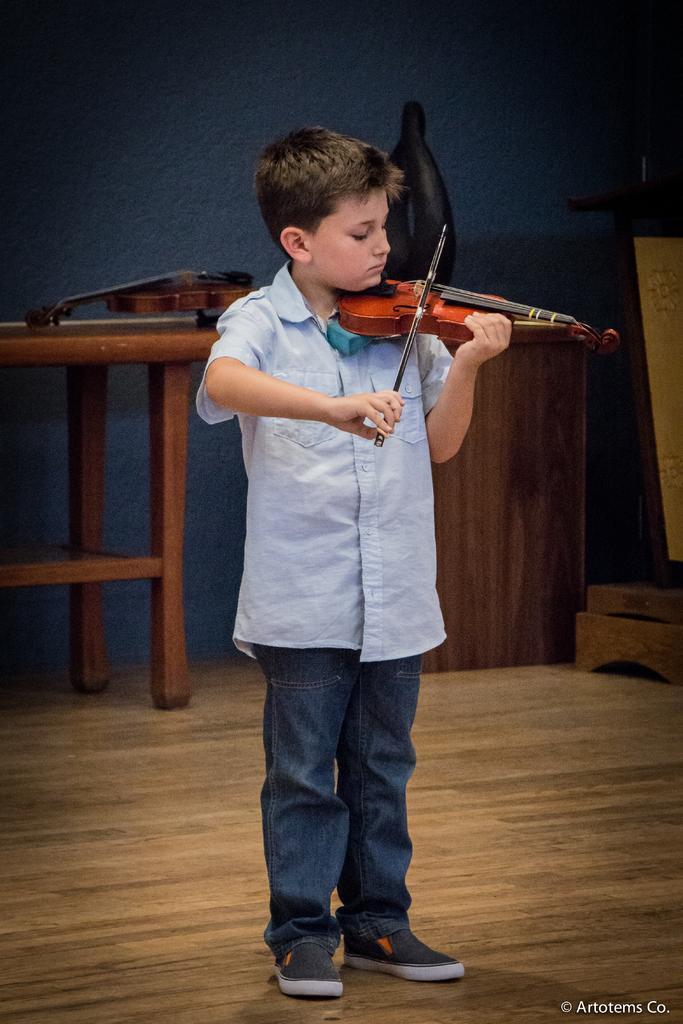Can you describe this image briefly? In this image has a boy playing a violin is a wearing blue shirt and jeans, shoes. At the left side there is a table on which violin is placed. At the right side there is another table on which idol is kept. 